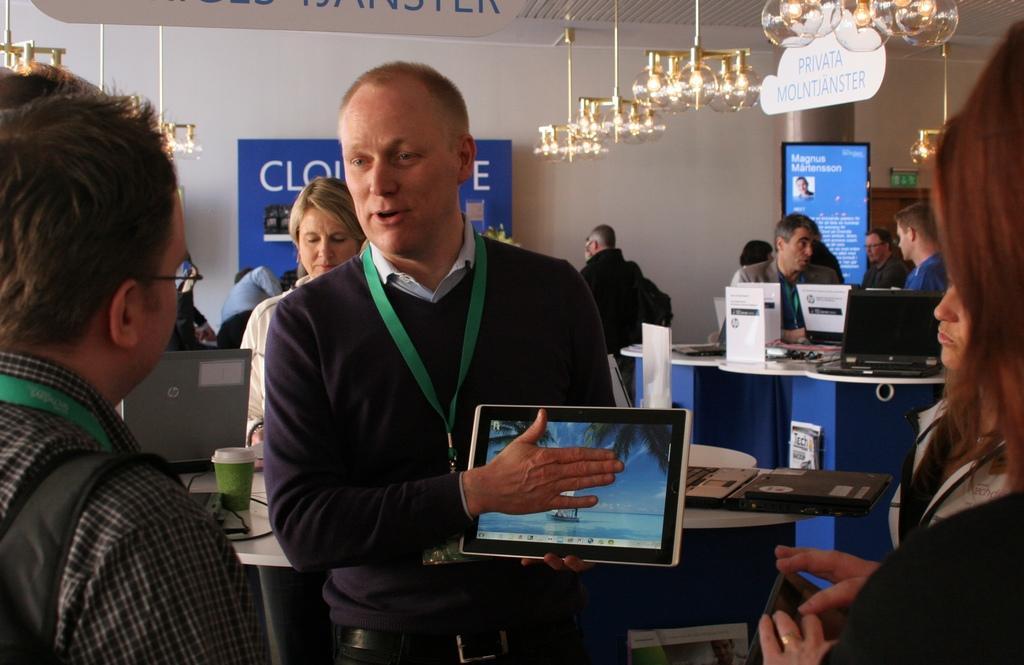Could you give a brief overview of what you see in this image? In this picture we can see a person holding tablet(device) in his hand. We can see a few people from left to right. There are some electronic devices and a cup on the tables. We can see a board and a poster There is a green color object and a wooden object in the background. Some lights and a white board is visible on top. 